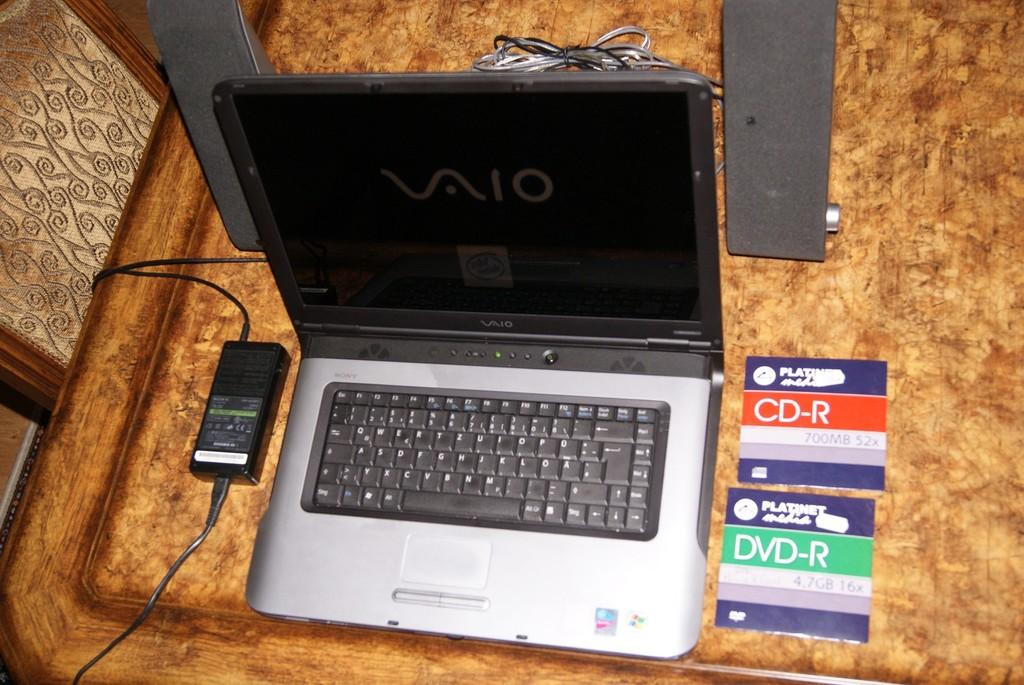<image>
Create a compact narrative representing the image presented. A Vaio laptop is open and next to a CD-R 700 mb and DVD-R  47 GB. 